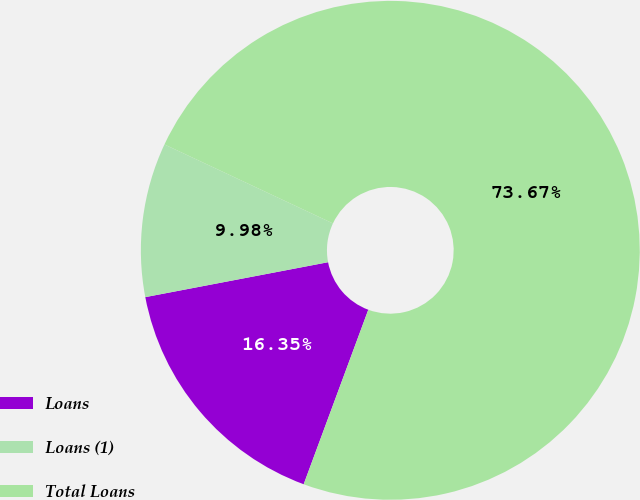<chart> <loc_0><loc_0><loc_500><loc_500><pie_chart><fcel>Loans<fcel>Loans (1)<fcel>Total Loans<nl><fcel>16.35%<fcel>9.98%<fcel>73.66%<nl></chart> 